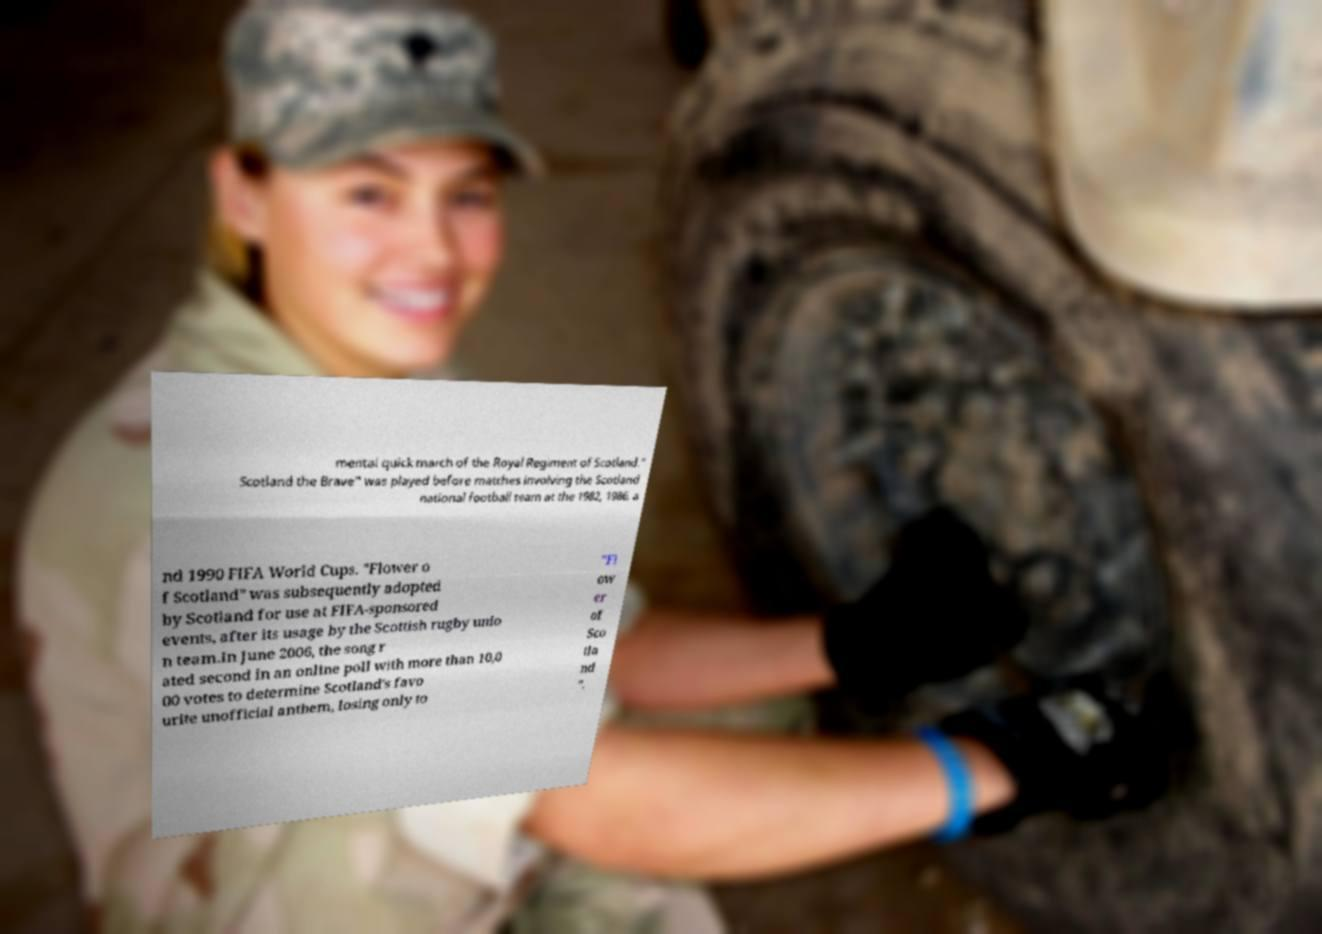Please identify and transcribe the text found in this image. mental quick march of the Royal Regiment of Scotland." Scotland the Brave" was played before matches involving the Scotland national football team at the 1982, 1986, a nd 1990 FIFA World Cups. "Flower o f Scotland" was subsequently adopted by Scotland for use at FIFA-sponsored events, after its usage by the Scottish rugby unio n team.In June 2006, the song r ated second in an online poll with more than 10,0 00 votes to determine Scotland's favo urite unofficial anthem, losing only to "Fl ow er of Sco tla nd ". 